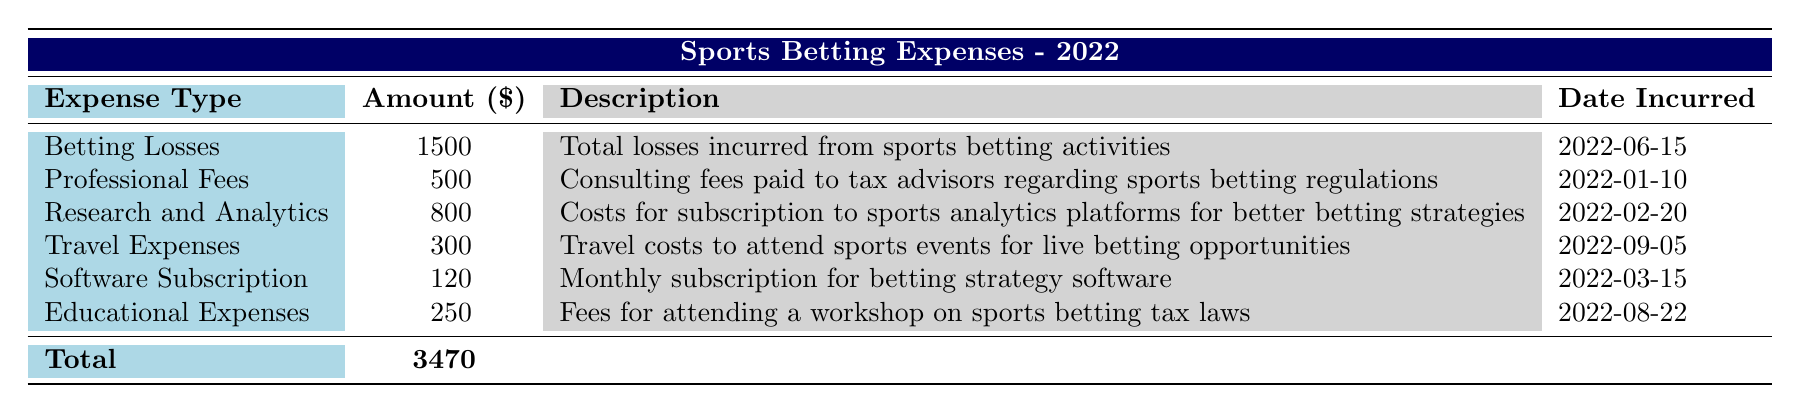What is the total amount of sports betting expenses listed in the table? To find the total amount, we sum all the individual amounts from each expense type. The amounts are 1500, 500, 800, 300, 120, and 250. Adding these together gives us 1500 + 500 + 800 + 300 + 120 + 250 = 3470.
Answer: 3470 What type of expense has the highest amount? By reviewing the amounts listed for each expense type, we see that Betting Losses has the highest amount at 1500, compared to the other amounts.
Answer: Betting Losses Is the amount for Travel Expenses more than 400? The amount for Travel Expenses is 300, which is less than 400. Therefore, the statement is false.
Answer: No How much did the individual spend on Professional Fees? The amount for Professional Fees is directly provided in the table as 500.
Answer: 500 What was the date of the highest expense incurred? The highest expense is Betting Losses which is 1500, and its date incurred is 2022-06-15. Therefore, this date corresponds to the highest expense.
Answer: 2022-06-15 Was the total amount spent on Educational Expenses greater than the amount spent on Software Subscription? The amount for Educational Expenses is 250, and for Software Subscription, it is 120. Since 250 is greater than 120, the statement is true.
Answer: Yes What is the average amount spent on Research and Analytics, Travel Expenses, and Educational Expenses? First, identify the amounts for those three expenses: Research and Analytics is 800, Travel Expenses is 300, and Educational Expenses is 250. Sum these amounts: 800 + 300 + 250 = 1350. There are 3 expenses, so to find the average, divide by 3: 1350 / 3 = 450.
Answer: 450 How many different types of expenses are related to professional consulting? Based on the table, the type of expense related to professional consulting is identified as Professional Fees, which is the only entry that pertains to consulting. Thus, the count is one.
Answer: 1 Which month had the least amount spent on sports betting expenses? By looking at the individual amounts for each month, we see Spending amounts: January (Professional Fees - 500), February (Research and Analytics - 800), March (Software Subscription - 120), June (Betting Losses - 1500), August (Educational Expenses - 250), and September (Travel Expenses - 300). The least amount is in March with 120.
Answer: March 